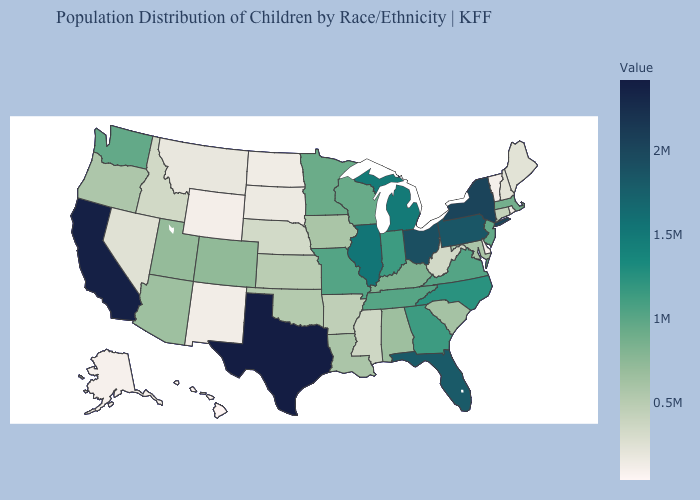Among the states that border Alabama , which have the highest value?
Quick response, please. Florida. Does Massachusetts have a higher value than Texas?
Concise answer only. No. Among the states that border Minnesota , which have the lowest value?
Quick response, please. North Dakota. Among the states that border Ohio , does Pennsylvania have the highest value?
Give a very brief answer. Yes. Which states hav the highest value in the South?
Give a very brief answer. Texas. Does the map have missing data?
Concise answer only. No. 